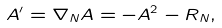<formula> <loc_0><loc_0><loc_500><loc_500>A ^ { \prime } = \nabla _ { N } A = - A ^ { 2 } - R _ { N } ,</formula> 